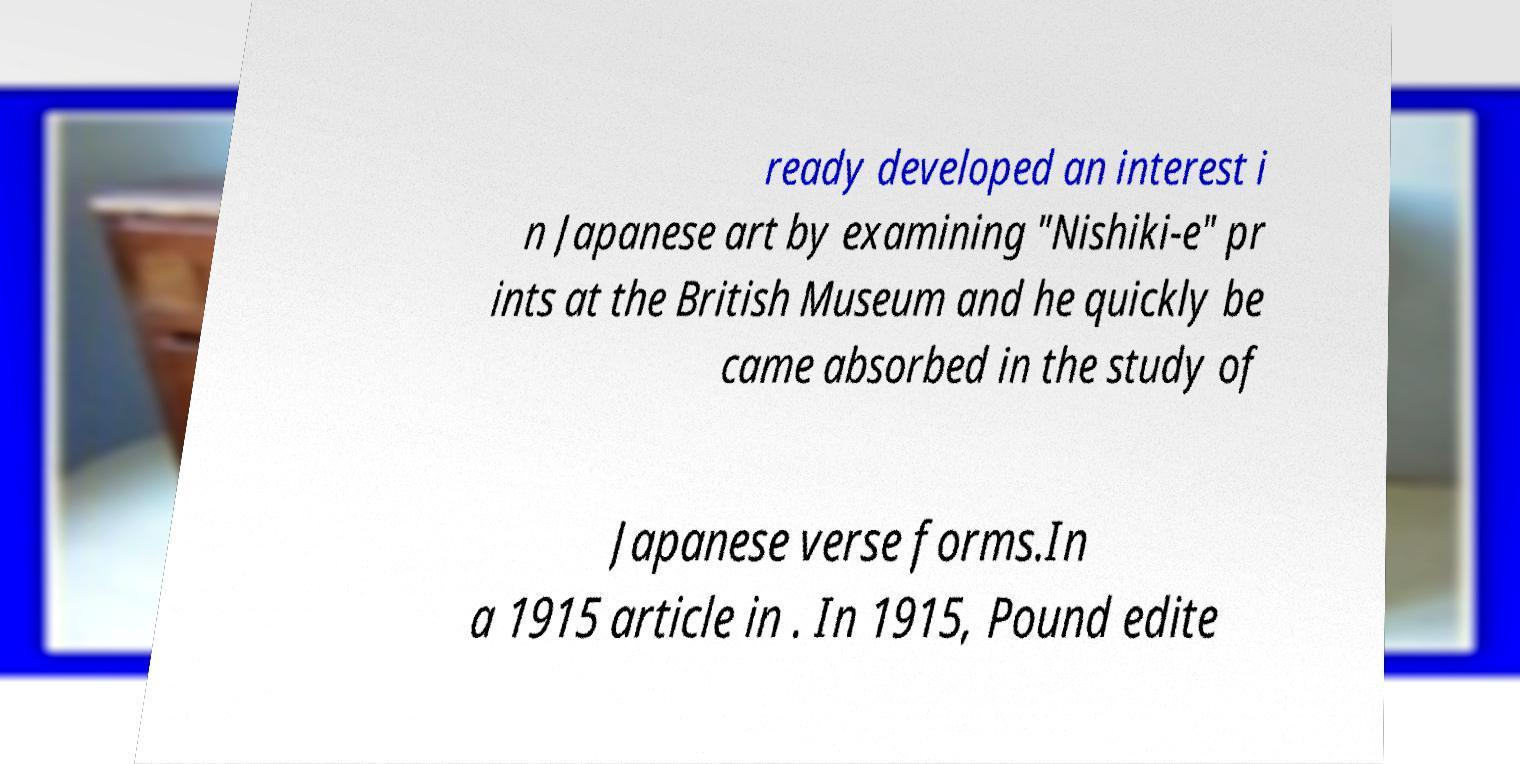What messages or text are displayed in this image? I need them in a readable, typed format. ready developed an interest i n Japanese art by examining "Nishiki-e" pr ints at the British Museum and he quickly be came absorbed in the study of Japanese verse forms.In a 1915 article in . In 1915, Pound edite 